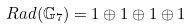<formula> <loc_0><loc_0><loc_500><loc_500>R a d ( \mathbb { G } _ { 7 } ) = { 1 } \oplus { 1 } \oplus { 1 } \oplus { 1 }</formula> 